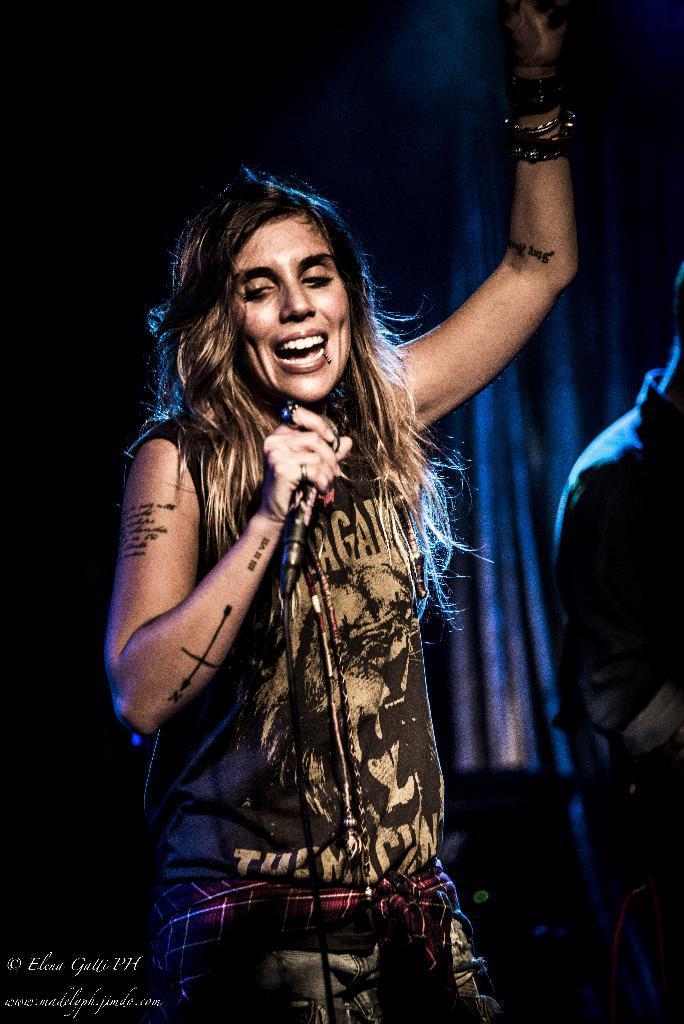Describe this image in one or two sentences. In this picture, there is a woman standing, holding a microphone in front of her. She is singing. In the background there is another person standing in the dark. 